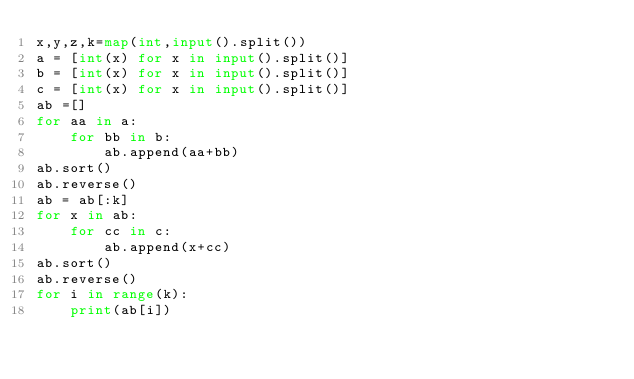Convert code to text. <code><loc_0><loc_0><loc_500><loc_500><_Python_>x,y,z,k=map(int,input().split())
a = [int(x) for x in input().split()]
b = [int(x) for x in input().split()]
c = [int(x) for x in input().split()]
ab =[]
for aa in a:
    for bb in b:
        ab.append(aa+bb)
ab.sort()
ab.reverse()
ab = ab[:k]
for x in ab:
    for cc in c:    
        ab.append(x+cc)
ab.sort()
ab.reverse()
for i in range(k):
    print(ab[i])</code> 